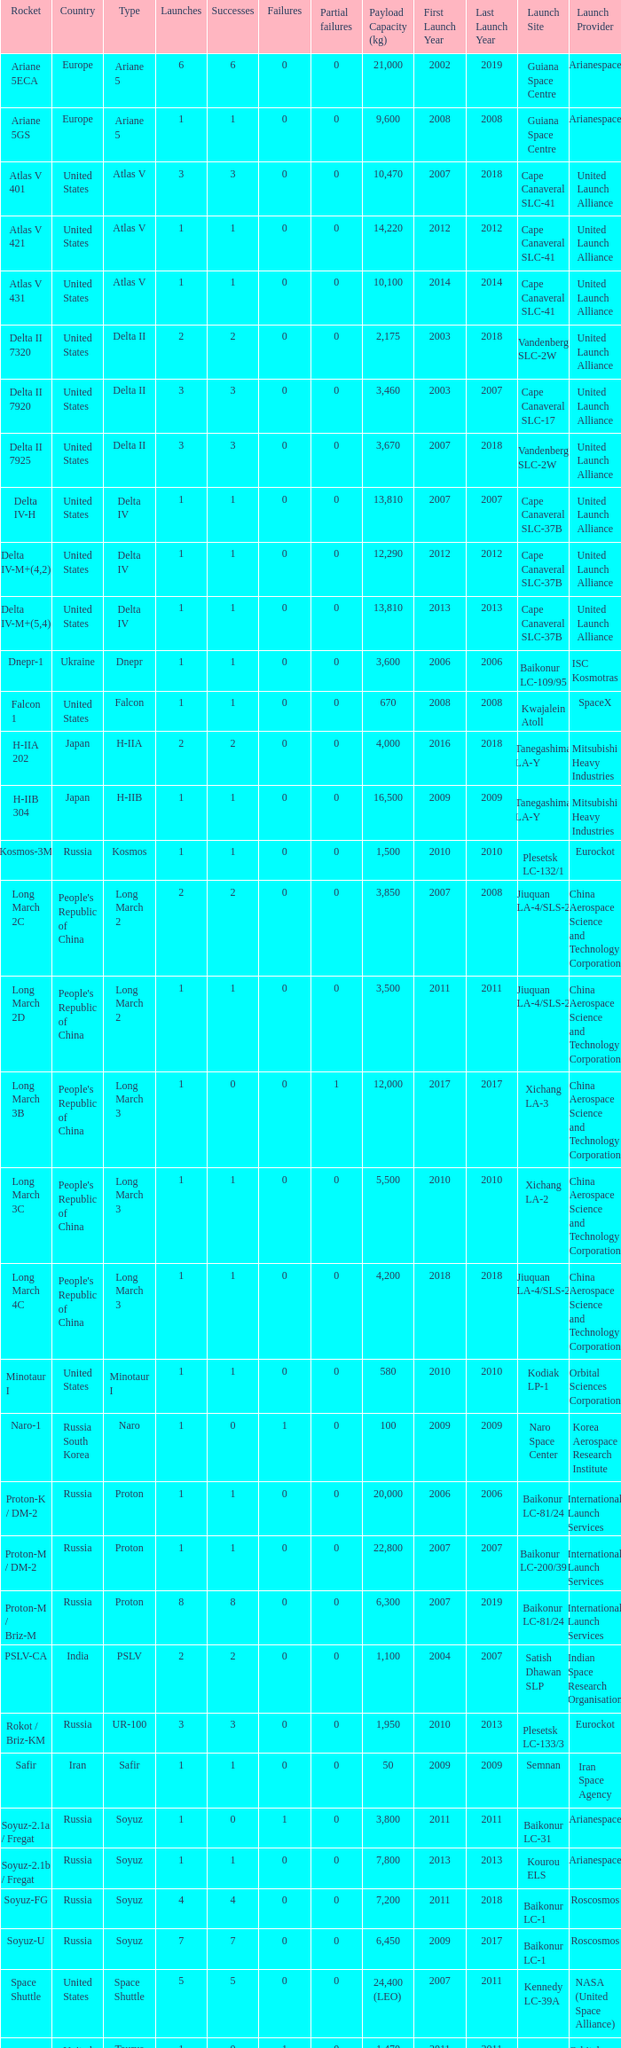What is the number of successes for rockets that have more than 3 launches, were based in Russia, are type soyuz and a rocket type of soyuz-u? 1.0. 